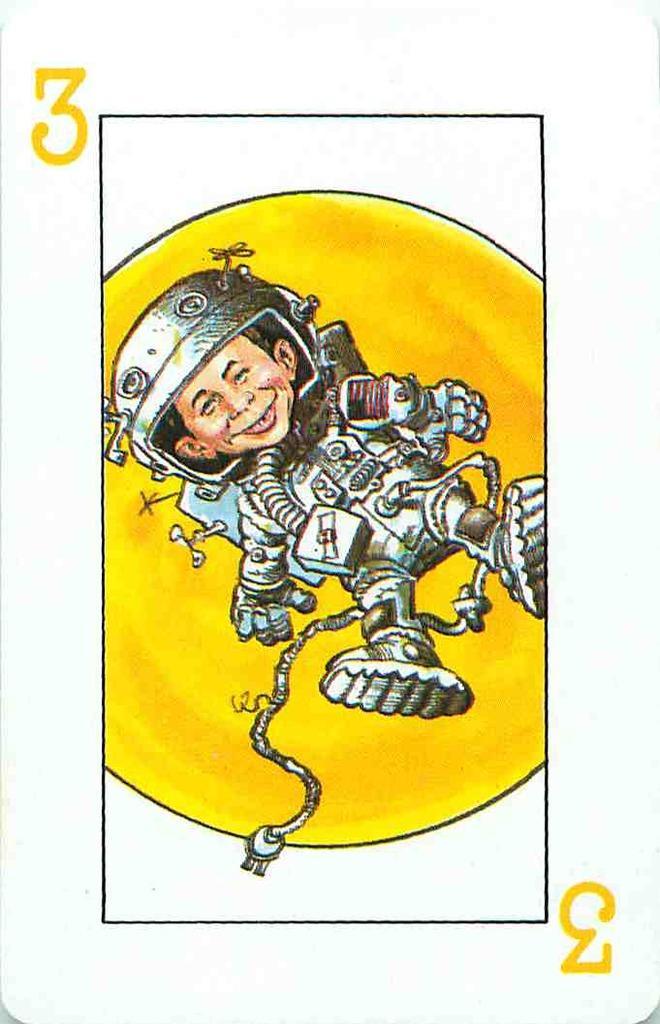In one or two sentences, can you explain what this image depicts? In this picture there is a white color playing card. In the front there is a cartoon type boy wearing astronaut suit. Behind there is a yellow background. 